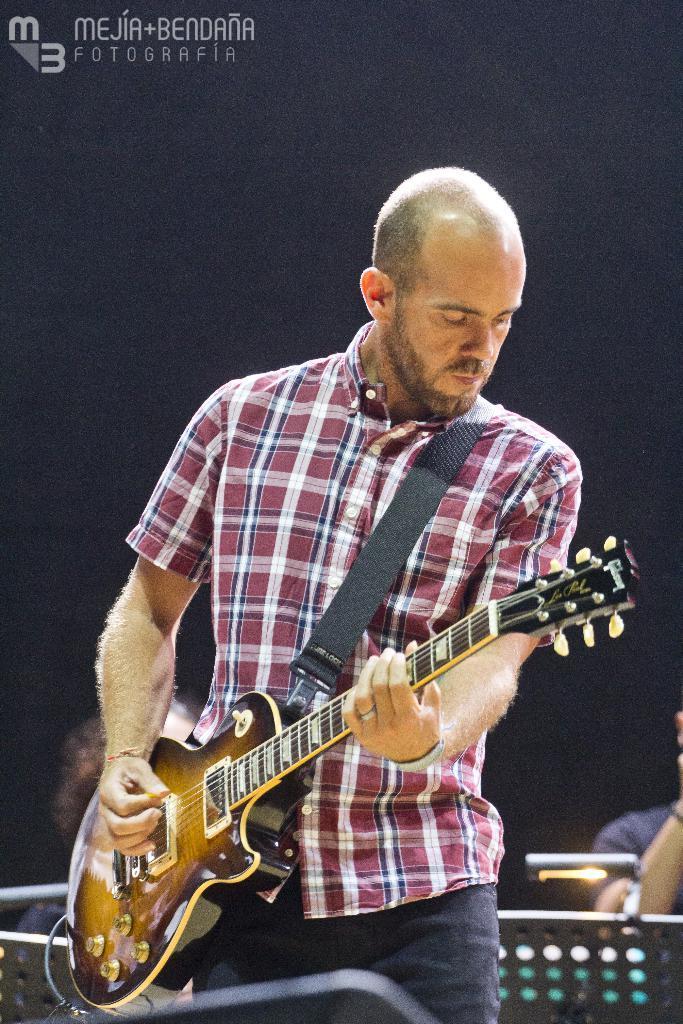How would you summarize this image in a sentence or two? In this Image I see a man who is standing and he is holding a guitar. In the background I see 2 persons. 